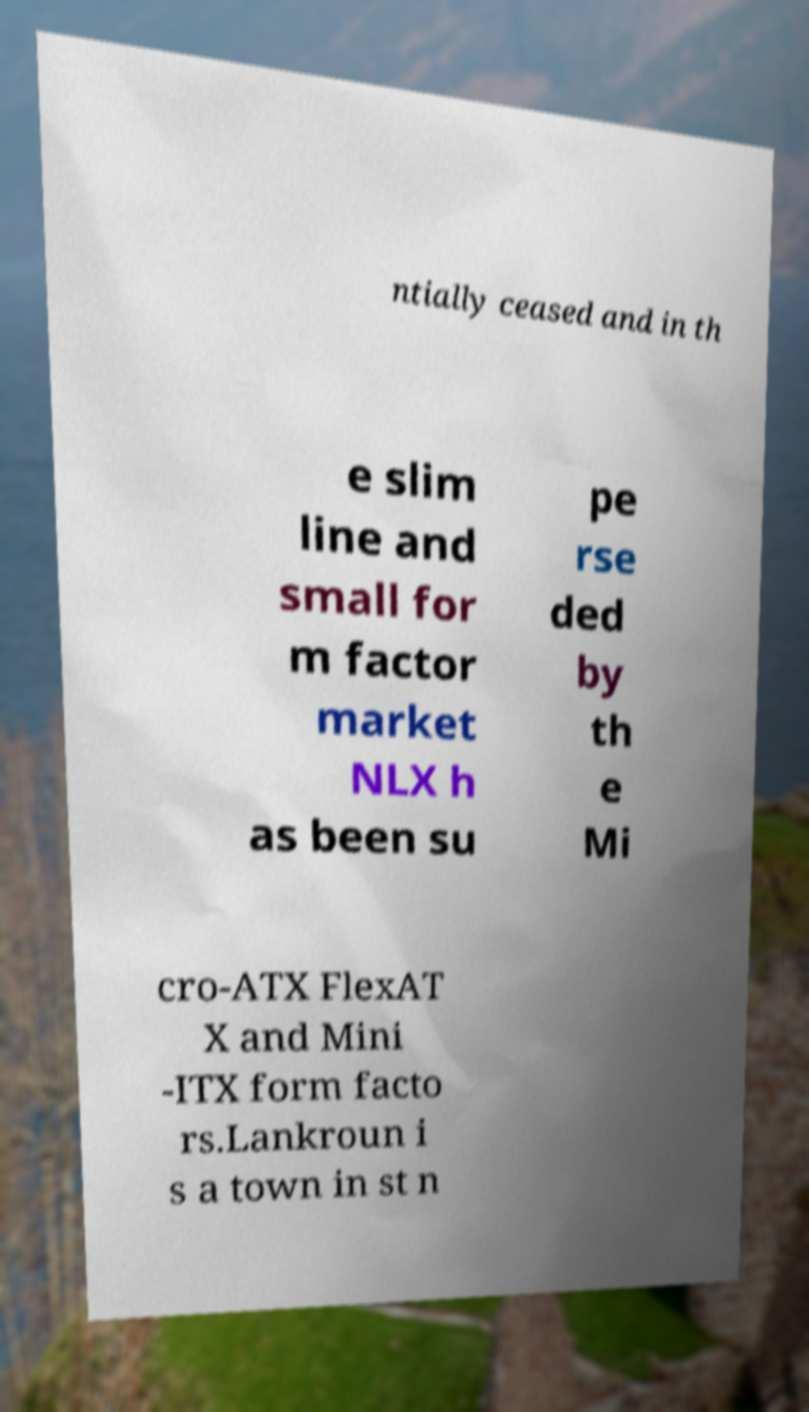Can you accurately transcribe the text from the provided image for me? ntially ceased and in th e slim line and small for m factor market NLX h as been su pe rse ded by th e Mi cro-ATX FlexAT X and Mini -ITX form facto rs.Lankroun i s a town in st n 